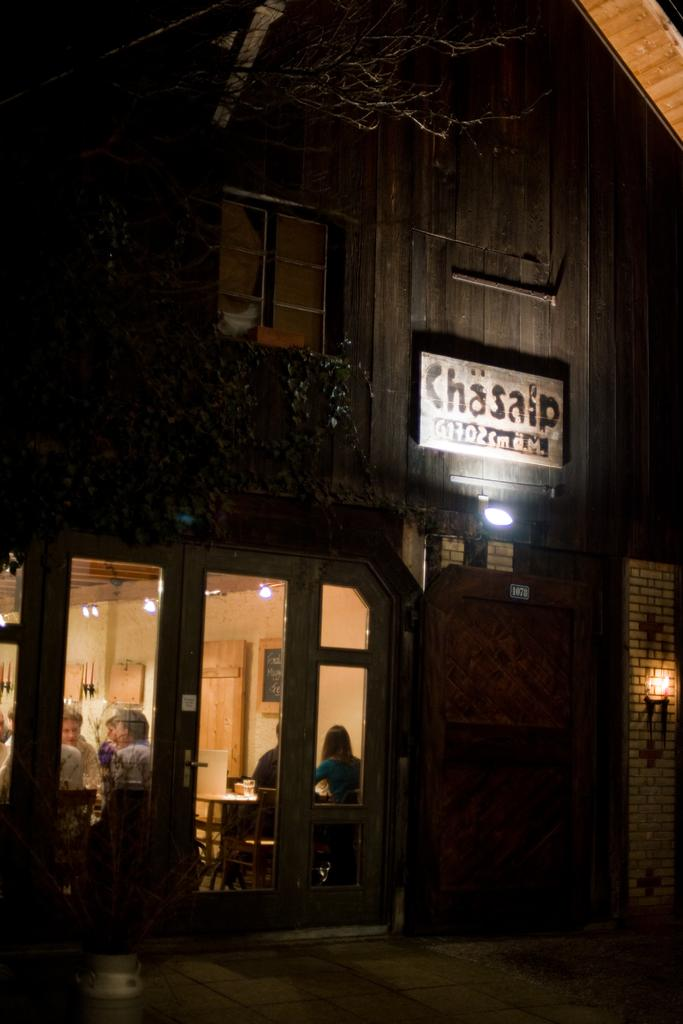Provide a one-sentence caption for the provided image. a sign that has the word Chasaip on it. 